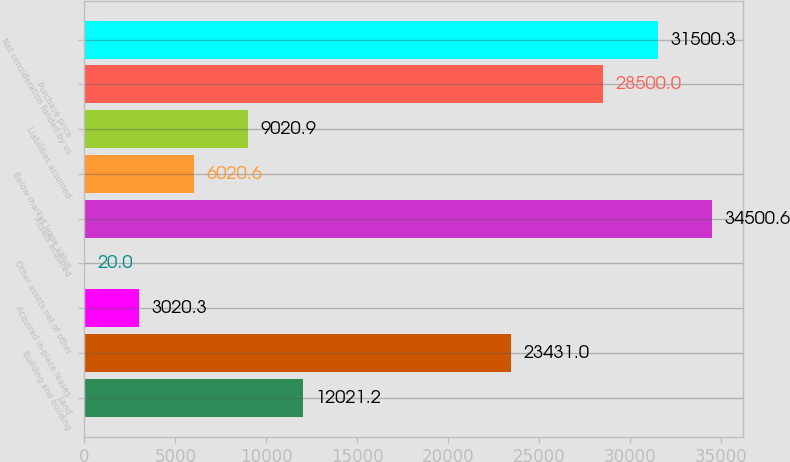Convert chart to OTSL. <chart><loc_0><loc_0><loc_500><loc_500><bar_chart><fcel>Land<fcel>Building and building<fcel>Acquired in-place leases<fcel>Other assets net of other<fcel>Assets acquired<fcel>Below-market lease value<fcel>Liabilities assumed<fcel>Purchase price<fcel>Net consideration funded by us<nl><fcel>12021.2<fcel>23431<fcel>3020.3<fcel>20<fcel>34500.6<fcel>6020.6<fcel>9020.9<fcel>28500<fcel>31500.3<nl></chart> 